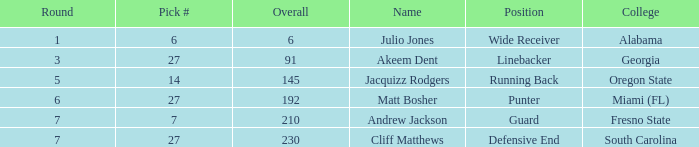Which highest pick number had Akeem Dent as a name and where the overall was less than 91? None. 